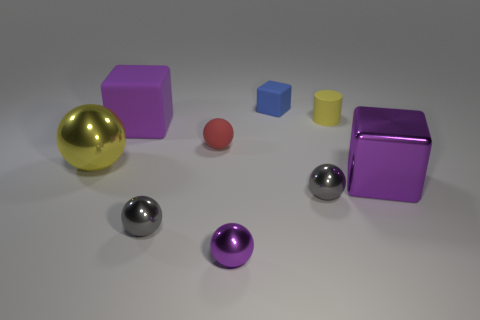There is another big purple object that is the same shape as the large matte thing; what is its material?
Keep it short and to the point. Metal. Do the large ball and the purple cube that is in front of the purple rubber object have the same material?
Ensure brevity in your answer.  Yes. There is a metallic object that is on the right side of the small yellow cylinder behind the red sphere; what is its shape?
Your response must be concise. Cube. What number of tiny objects are gray metallic spheres or purple cubes?
Your response must be concise. 2. What number of tiny red things are the same shape as the big yellow thing?
Give a very brief answer. 1. Do the tiny red rubber object and the tiny gray thing that is to the left of the red sphere have the same shape?
Offer a very short reply. Yes. There is a yellow cylinder; how many yellow rubber cylinders are behind it?
Provide a short and direct response. 0. Are there any red objects of the same size as the rubber ball?
Your answer should be compact. No. There is a big shiny thing that is behind the large purple shiny object; is it the same shape as the small yellow matte thing?
Your response must be concise. No. What is the color of the tiny cube?
Offer a terse response. Blue. 